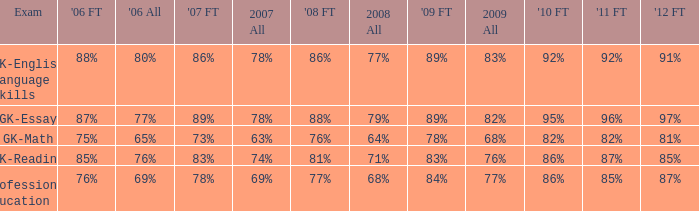What is the percentage for first time in 2012 when it was 82% for all in 2009? 97%. 